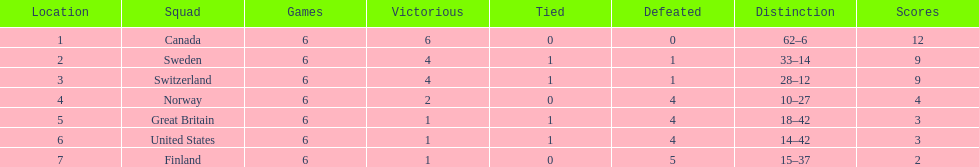What was the sum of points achieved by great britain? 3. 